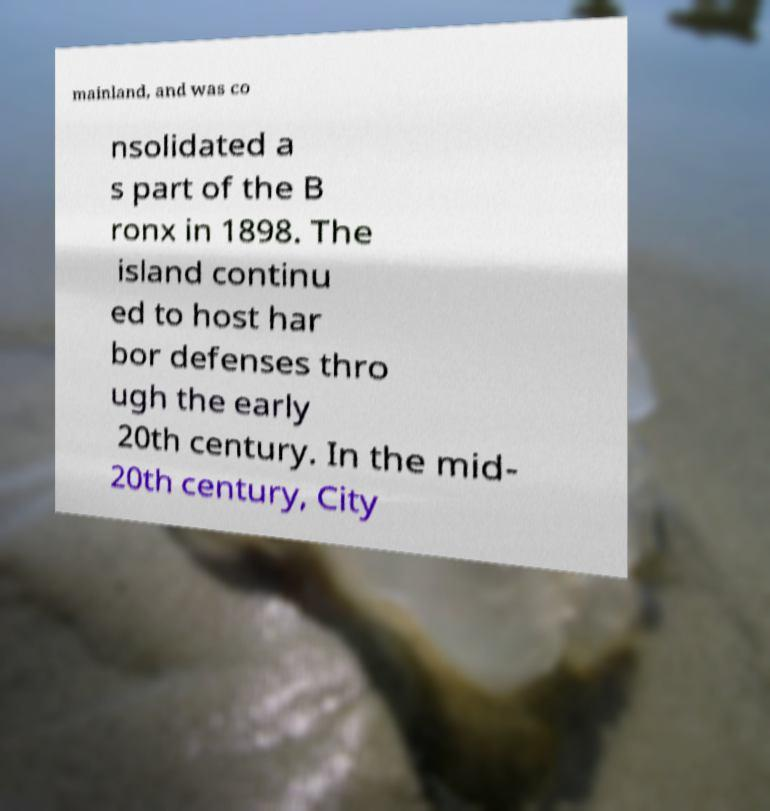For documentation purposes, I need the text within this image transcribed. Could you provide that? mainland, and was co nsolidated a s part of the B ronx in 1898. The island continu ed to host har bor defenses thro ugh the early 20th century. In the mid- 20th century, City 